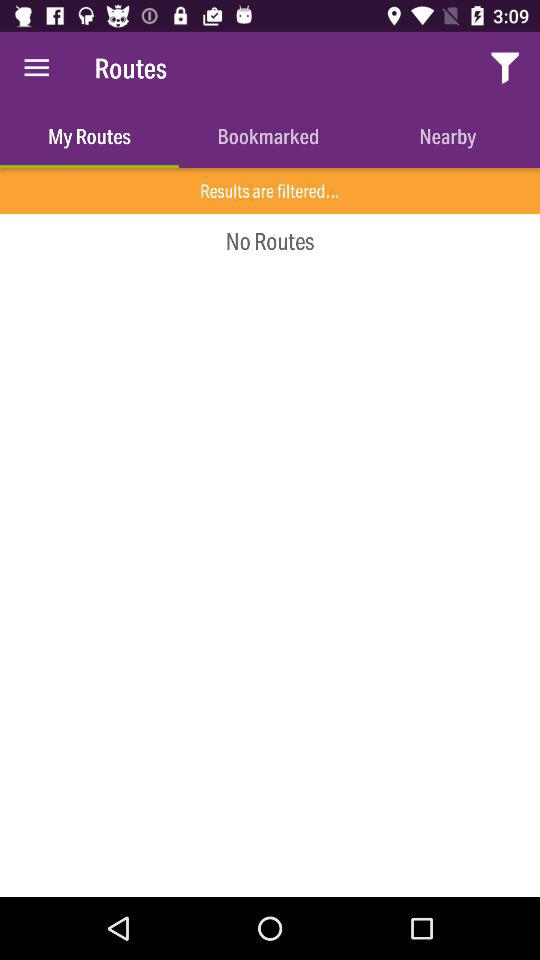Which tab is selected? The selected tab is "My Routes". 